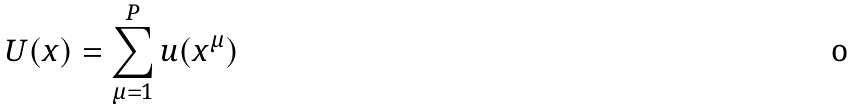<formula> <loc_0><loc_0><loc_500><loc_500>U ( x ) = \sum _ { \mu = 1 } ^ { P } u ( x ^ { \mu } )</formula> 